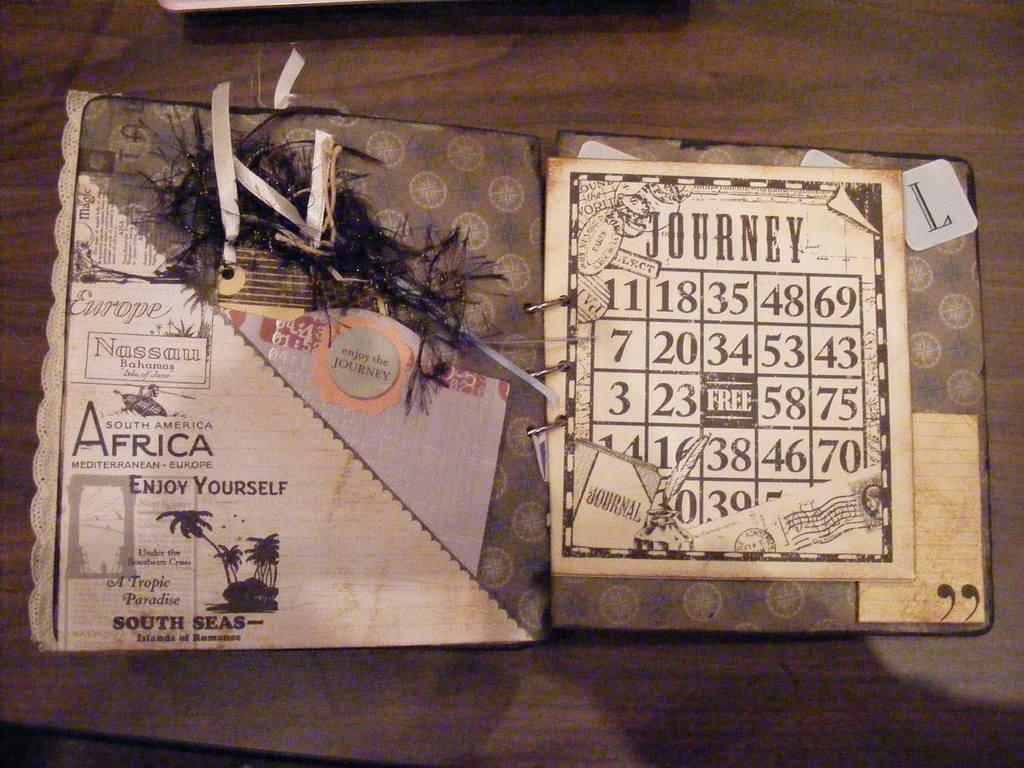<image>
Present a compact description of the photo's key features. A book is open with the word Africa in larger print on the left side. 